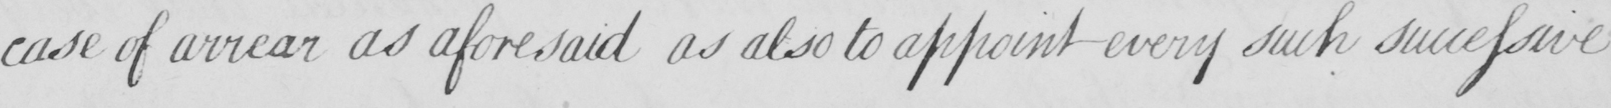What is written in this line of handwriting? case of arrear as aforesaid as also to appoint every such successive 